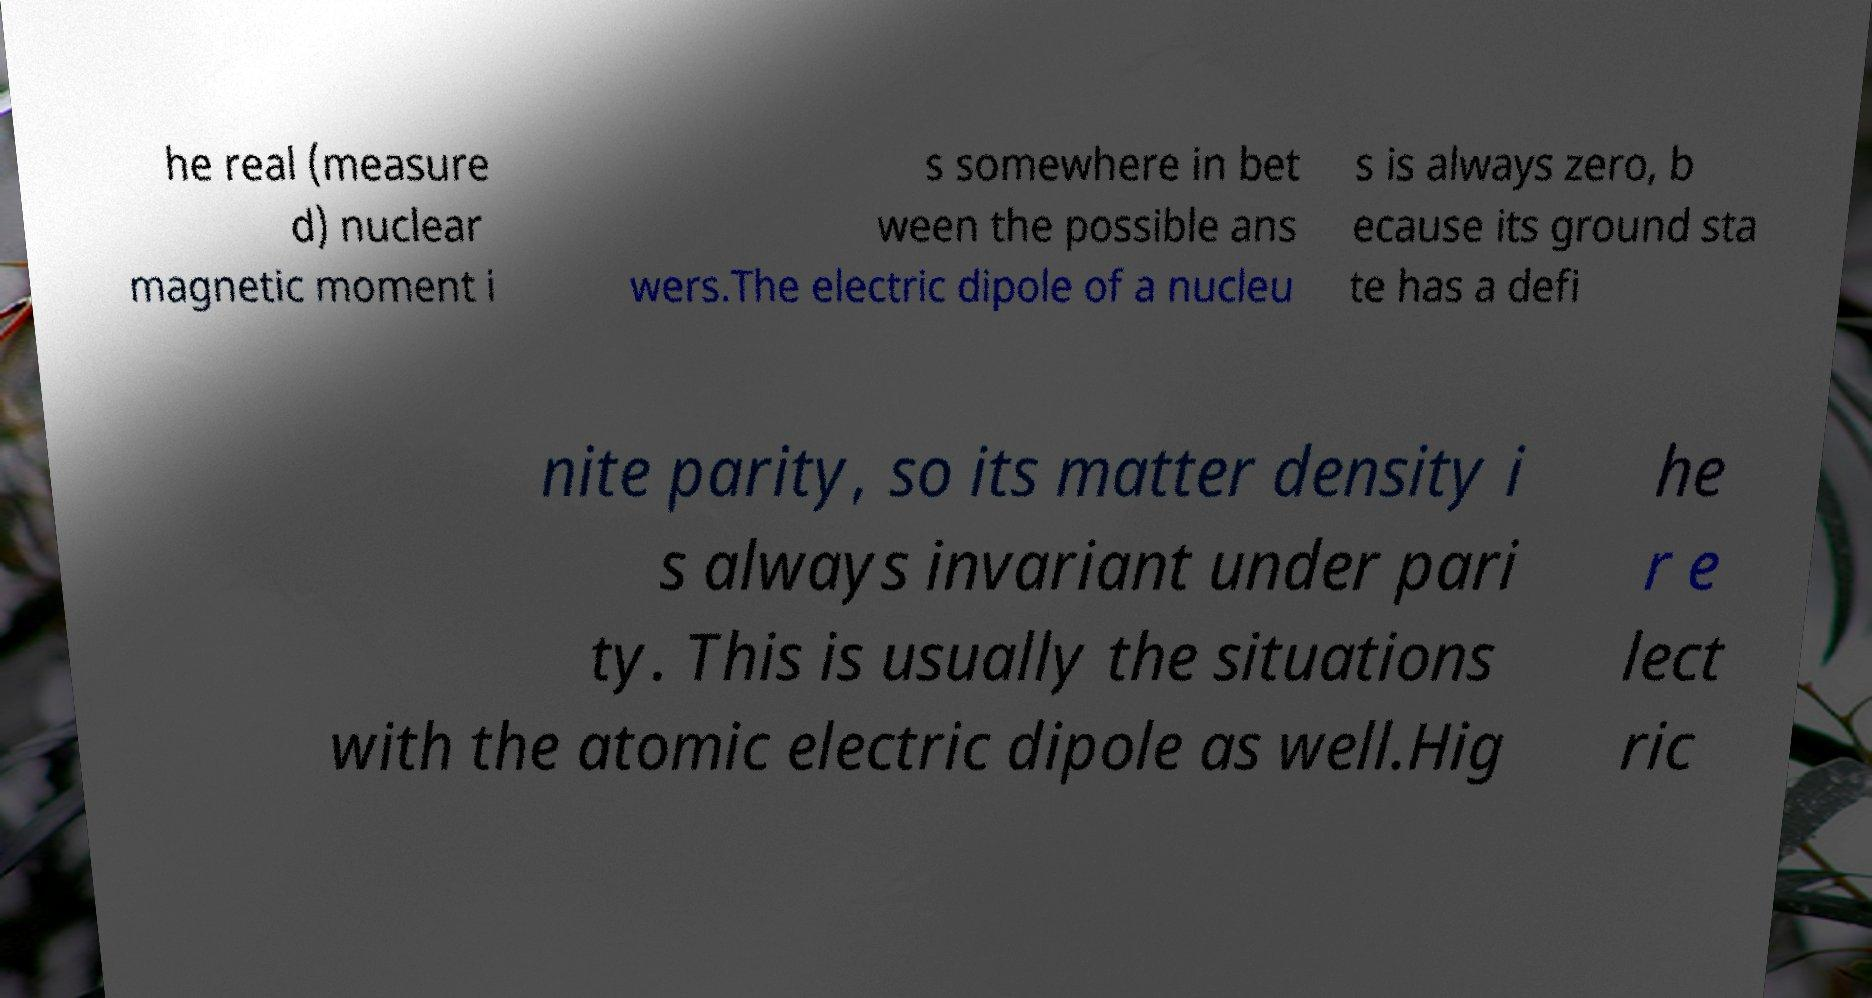Please read and relay the text visible in this image. What does it say? he real (measure d) nuclear magnetic moment i s somewhere in bet ween the possible ans wers.The electric dipole of a nucleu s is always zero, b ecause its ground sta te has a defi nite parity, so its matter density i s always invariant under pari ty. This is usually the situations with the atomic electric dipole as well.Hig he r e lect ric 